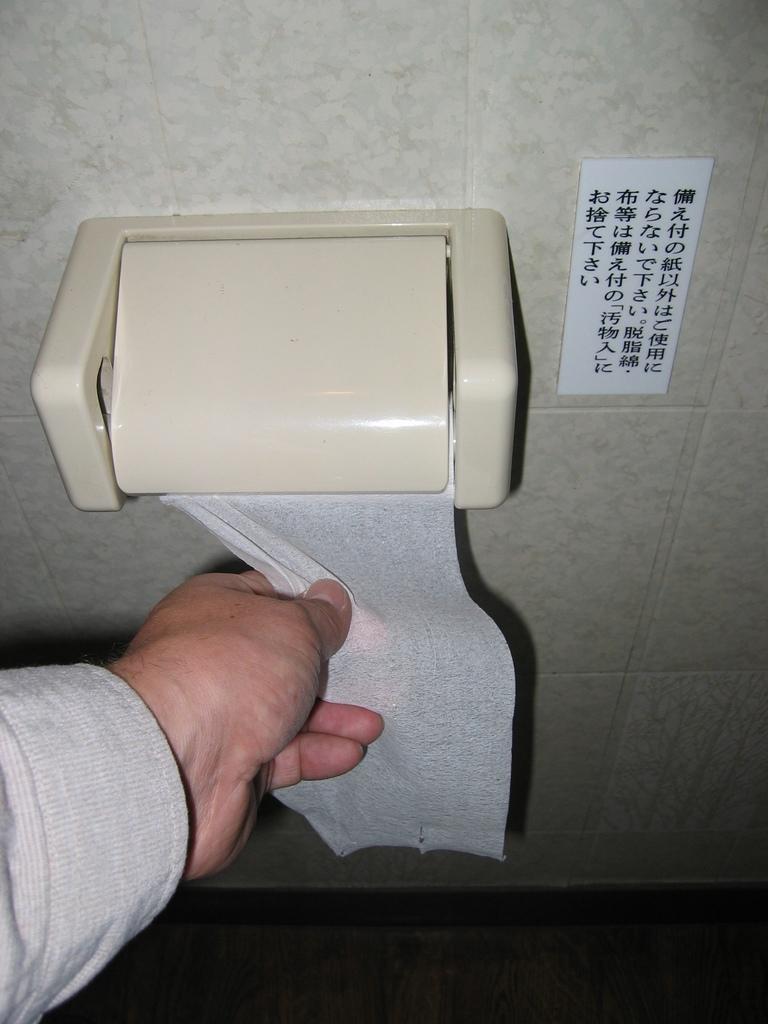Describe this image in one or two sentences. In this image we can see a tissue paper dispenser is attached to the wall and one human hand is holding an issue. There is a floor at the bottom of the image. And we can see one board with some text on the wall. 